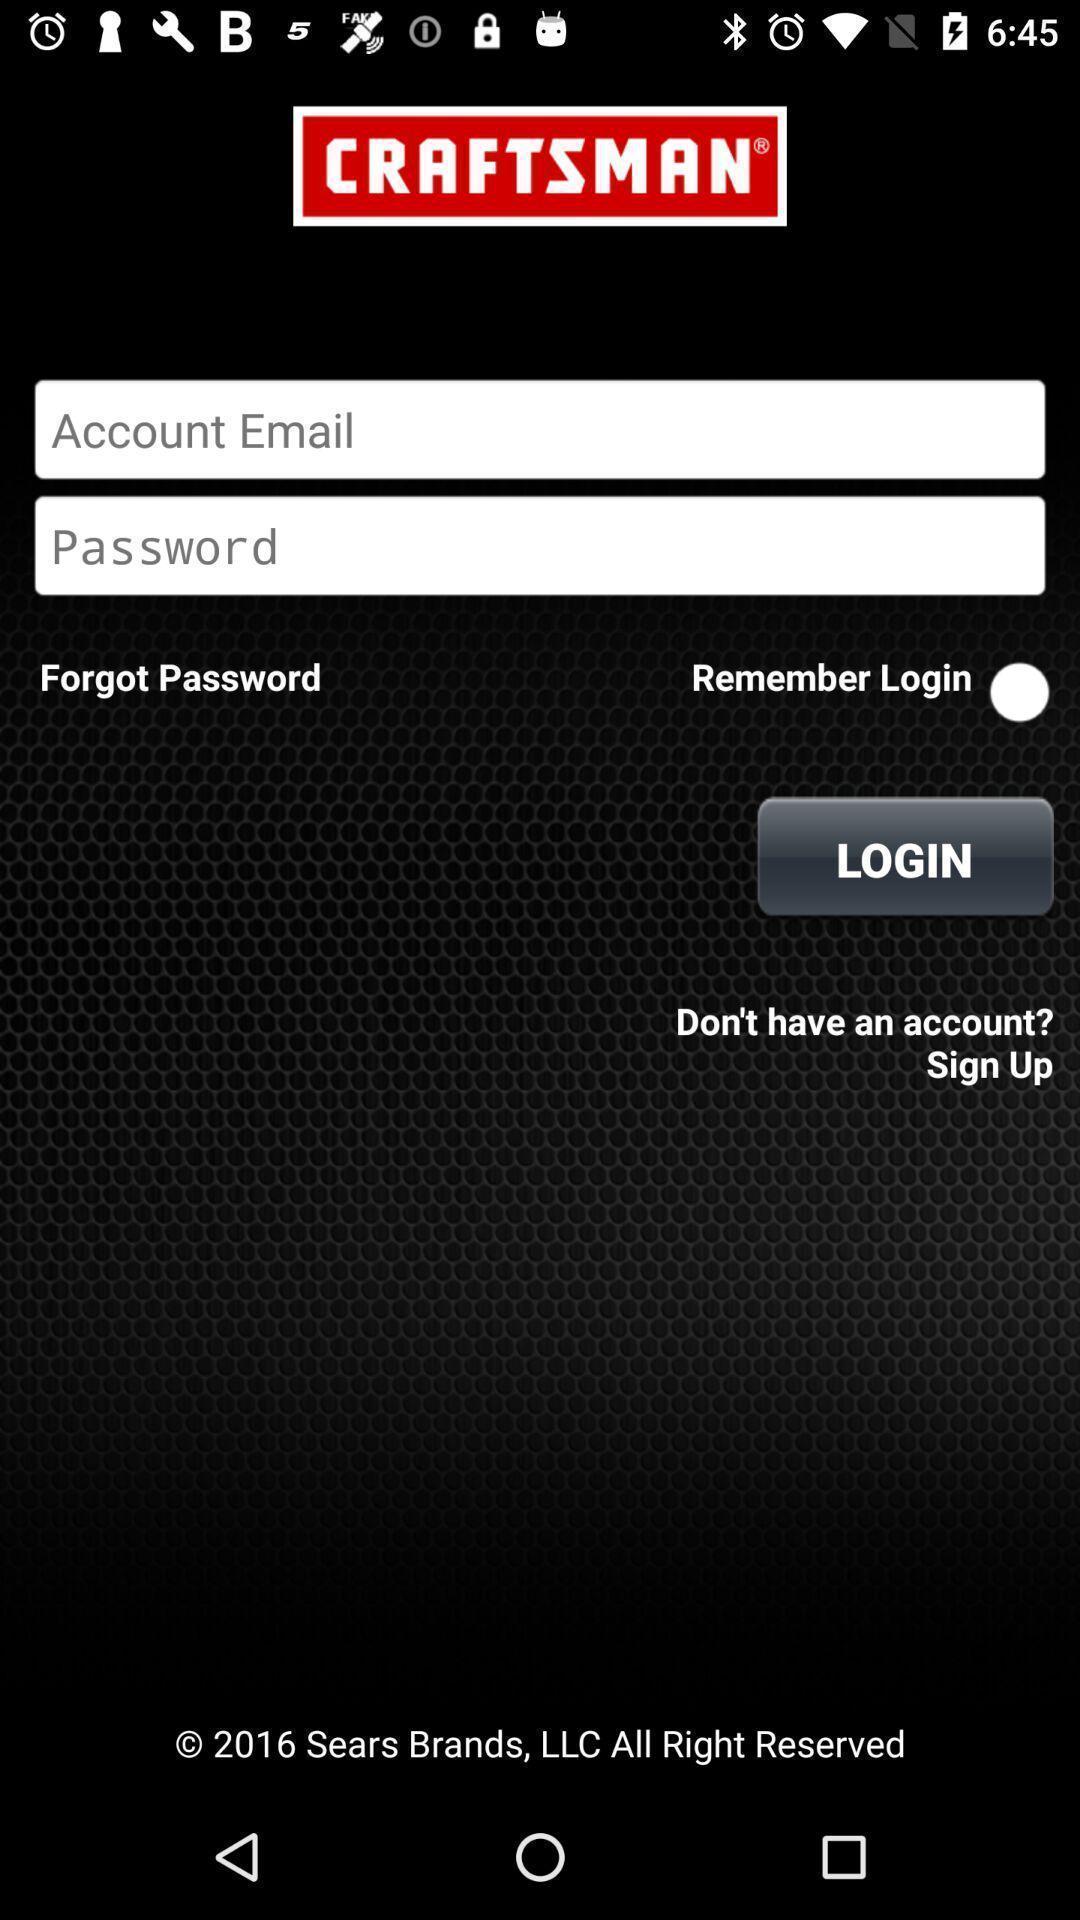Give me a summary of this screen capture. Login page to create an account. 